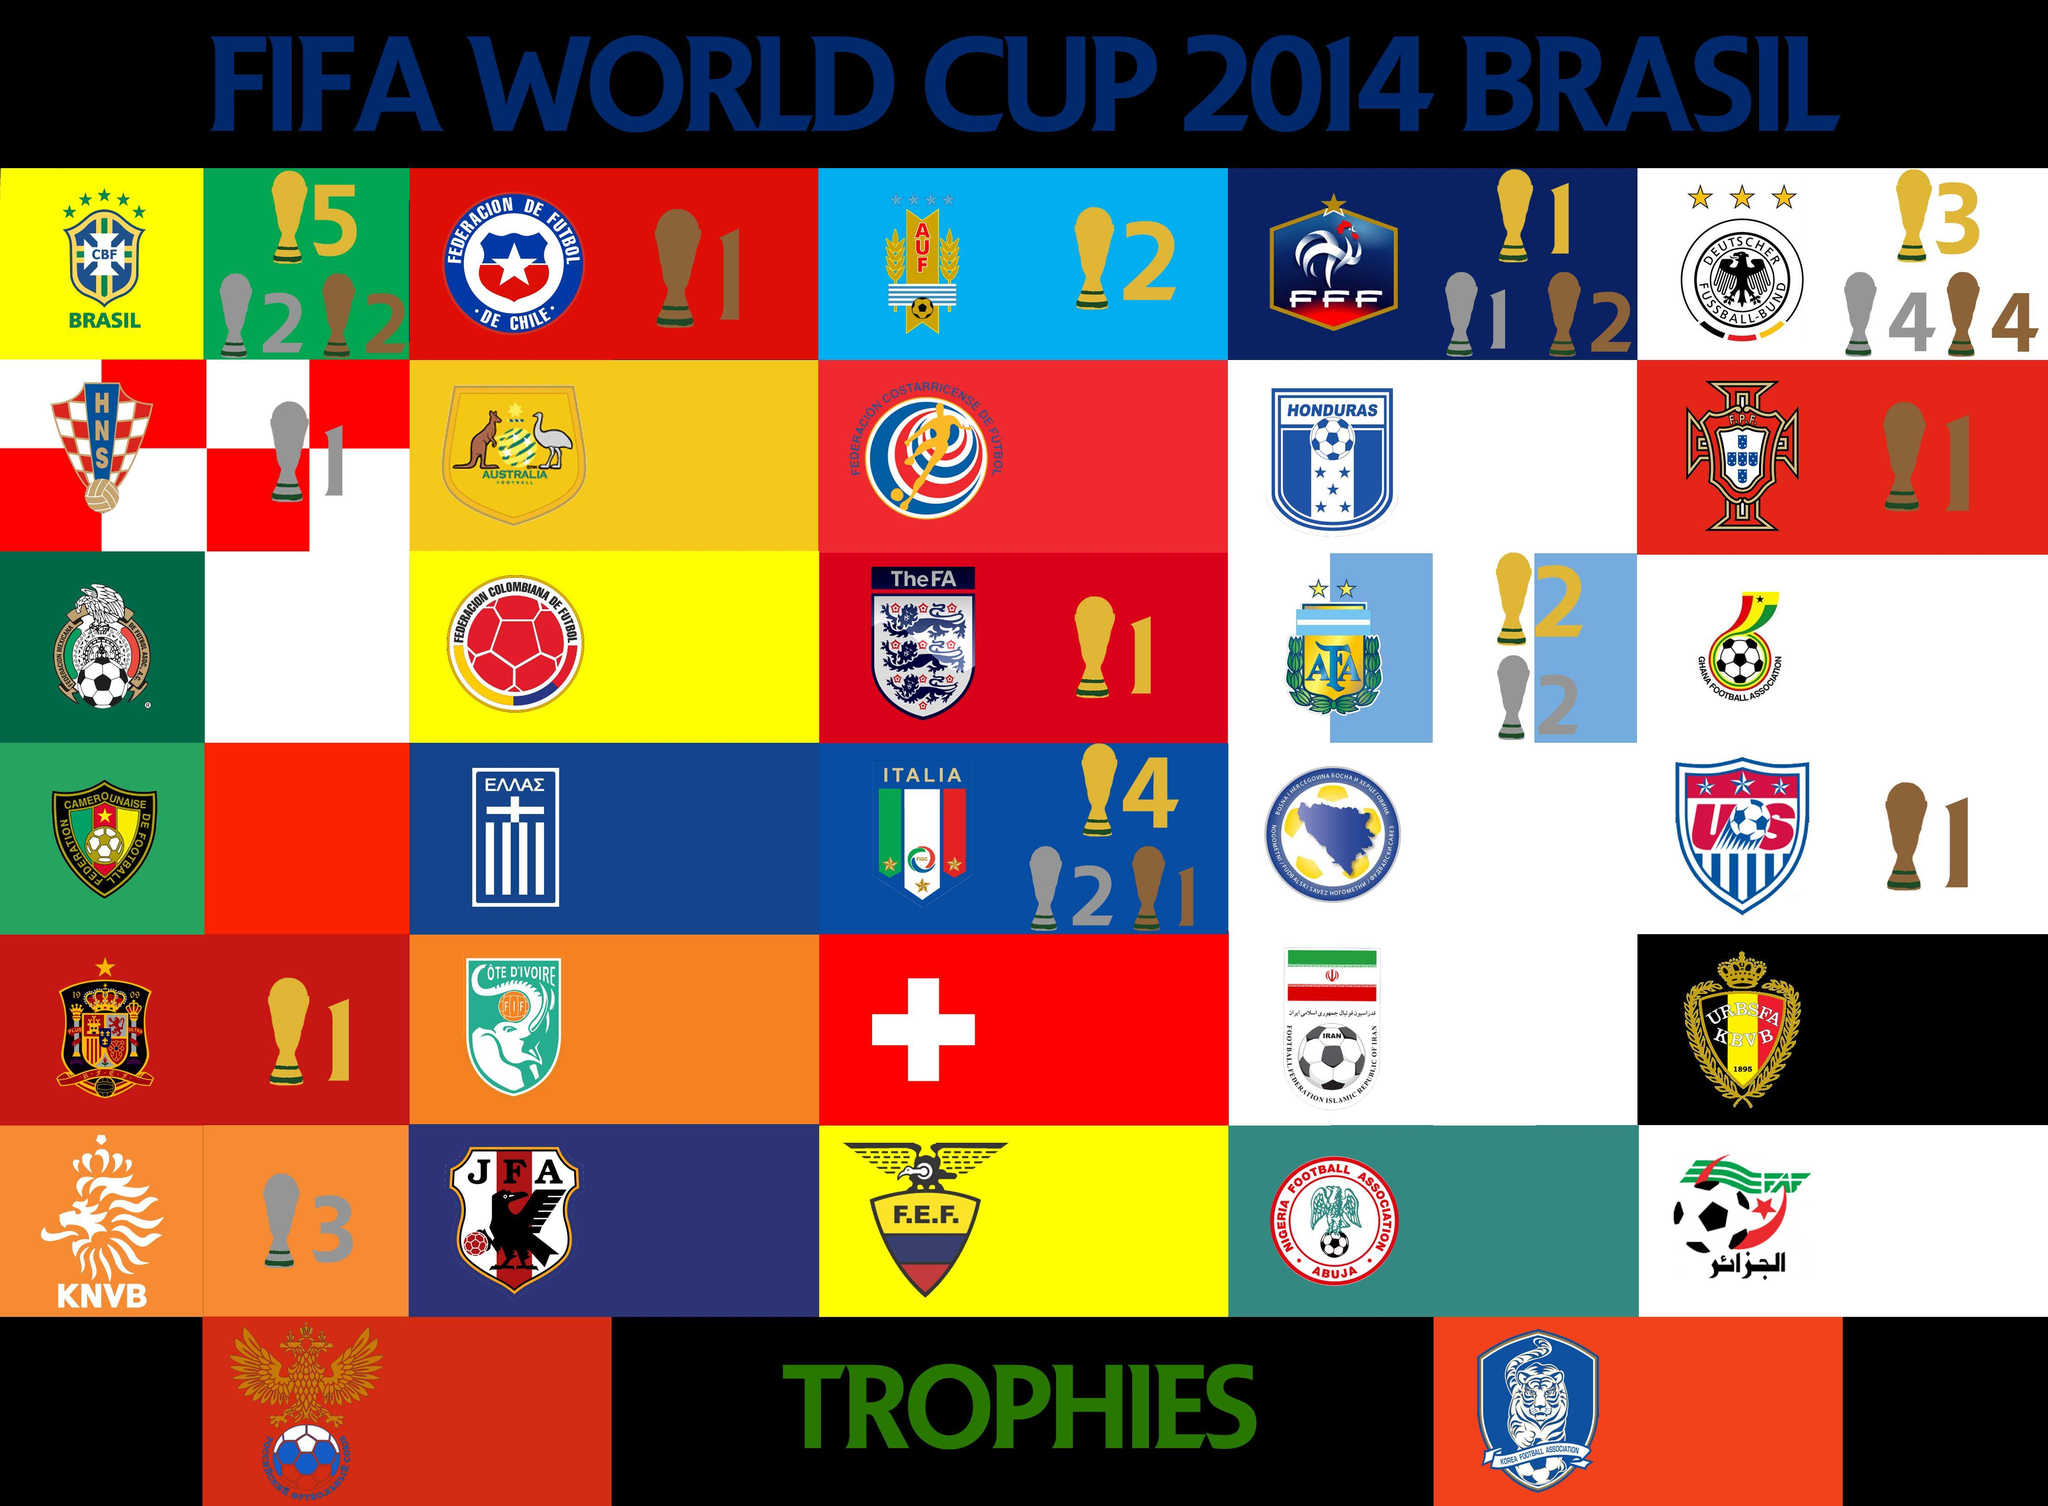Which country's football association is represented by a Kangaroo and an Ostrich?
Answer the question with a short phrase. Australia Which football association has the image of a tiger? Korean Football Association 